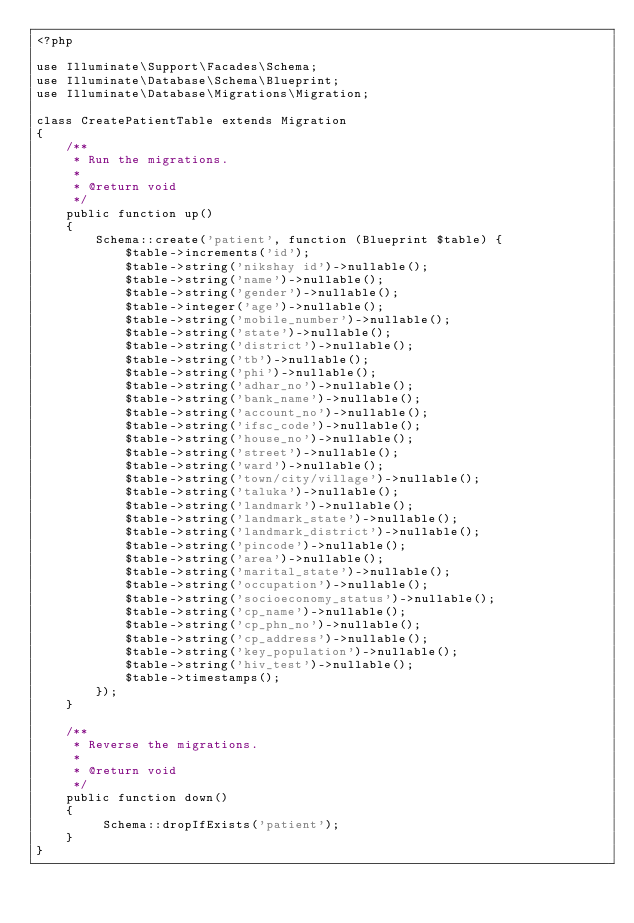<code> <loc_0><loc_0><loc_500><loc_500><_PHP_><?php

use Illuminate\Support\Facades\Schema;
use Illuminate\Database\Schema\Blueprint;
use Illuminate\Database\Migrations\Migration;

class CreatePatientTable extends Migration
{
    /**
     * Run the migrations.
     *
     * @return void
     */
    public function up()
    {
        Schema::create('patient', function (Blueprint $table) {
            $table->increments('id');
            $table->string('nikshay id')->nullable();
            $table->string('name')->nullable();
            $table->string('gender')->nullable();
            $table->integer('age')->nullable();
            $table->string('mobile_number')->nullable();
            $table->string('state')->nullable();
            $table->string('district')->nullable();
            $table->string('tb')->nullable();
            $table->string('phi')->nullable();
            $table->string('adhar_no')->nullable();
            $table->string('bank_name')->nullable();
            $table->string('account_no')->nullable();
            $table->string('ifsc_code')->nullable();
            $table->string('house_no')->nullable();
            $table->string('street')->nullable();
            $table->string('ward')->nullable();
            $table->string('town/city/village')->nullable();
            $table->string('taluka')->nullable();
            $table->string('landmark')->nullable();
            $table->string('landmark_state')->nullable();
            $table->string('landmark_district')->nullable();
            $table->string('pincode')->nullable();
            $table->string('area')->nullable();
            $table->string('marital_state')->nullable();
            $table->string('occupation')->nullable();
            $table->string('socioeconomy_status')->nullable();
            $table->string('cp_name')->nullable();
            $table->string('cp_phn_no')->nullable();
            $table->string('cp_address')->nullable();
            $table->string('key_population')->nullable();
            $table->string('hiv_test')->nullable();
            $table->timestamps();
        });
    }

    /**
     * Reverse the migrations.
     *
     * @return void
     */
    public function down()
    {
         Schema::dropIfExists('patient');
    }
}
</code> 